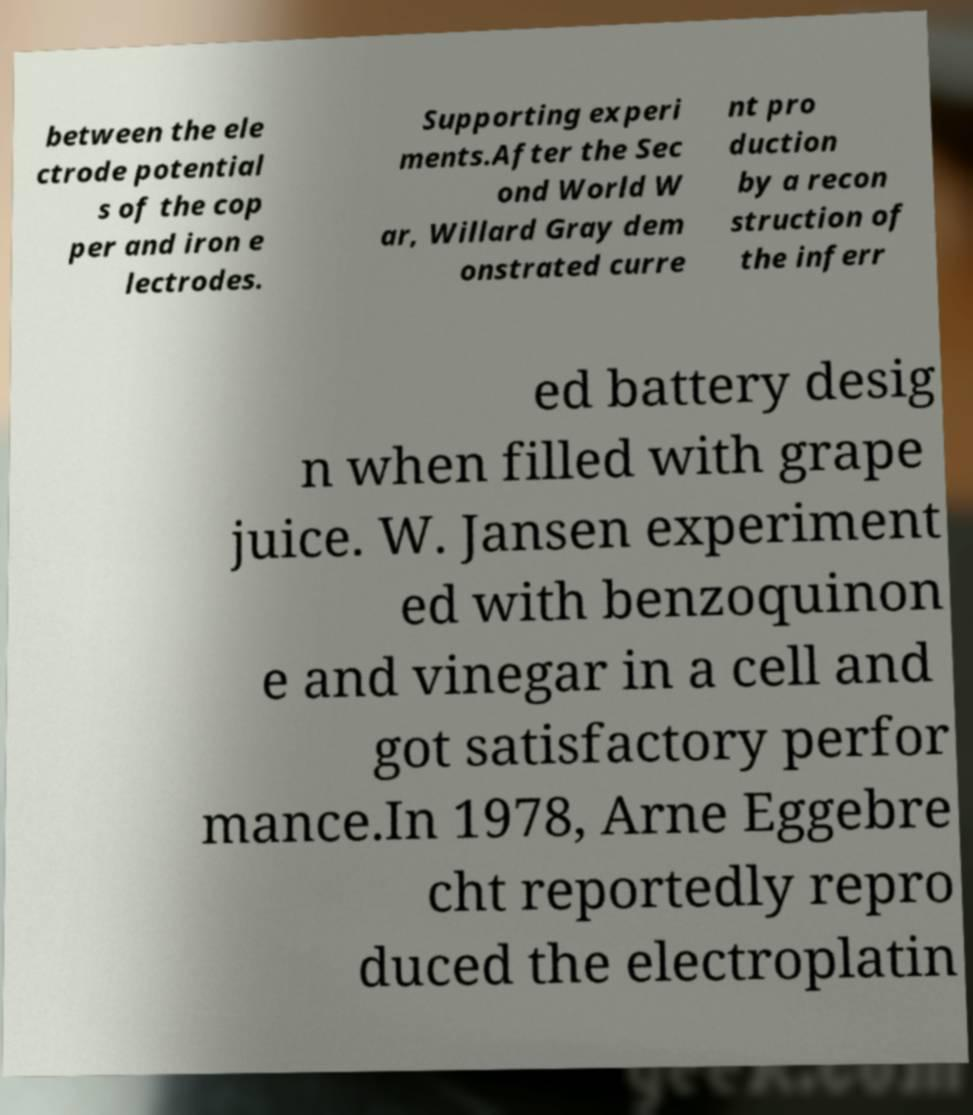I need the written content from this picture converted into text. Can you do that? between the ele ctrode potential s of the cop per and iron e lectrodes. Supporting experi ments.After the Sec ond World W ar, Willard Gray dem onstrated curre nt pro duction by a recon struction of the inferr ed battery desig n when filled with grape juice. W. Jansen experiment ed with benzoquinon e and vinegar in a cell and got satisfactory perfor mance.In 1978, Arne Eggebre cht reportedly repro duced the electroplatin 